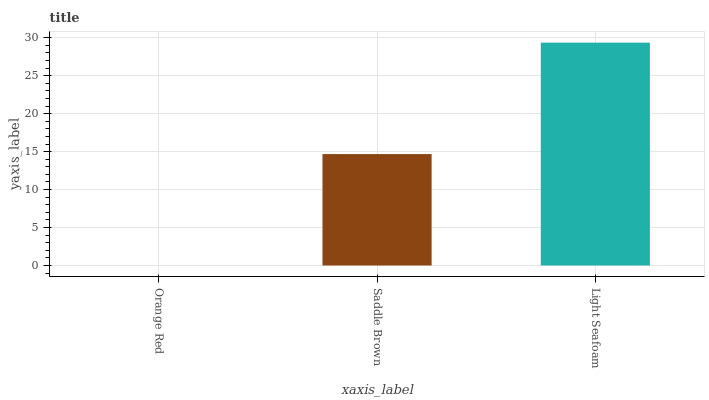Is Orange Red the minimum?
Answer yes or no. Yes. Is Light Seafoam the maximum?
Answer yes or no. Yes. Is Saddle Brown the minimum?
Answer yes or no. No. Is Saddle Brown the maximum?
Answer yes or no. No. Is Saddle Brown greater than Orange Red?
Answer yes or no. Yes. Is Orange Red less than Saddle Brown?
Answer yes or no. Yes. Is Orange Red greater than Saddle Brown?
Answer yes or no. No. Is Saddle Brown less than Orange Red?
Answer yes or no. No. Is Saddle Brown the high median?
Answer yes or no. Yes. Is Saddle Brown the low median?
Answer yes or no. Yes. Is Light Seafoam the high median?
Answer yes or no. No. Is Orange Red the low median?
Answer yes or no. No. 